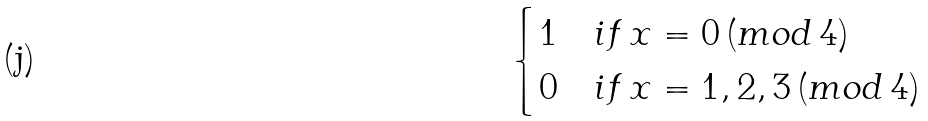<formula> <loc_0><loc_0><loc_500><loc_500>\begin{cases} 1 & i f \, x = 0 \, ( m o d \, 4 ) \\ 0 & i f \, x = 1 , 2 , 3 \, ( m o d \, 4 ) \end{cases}</formula> 